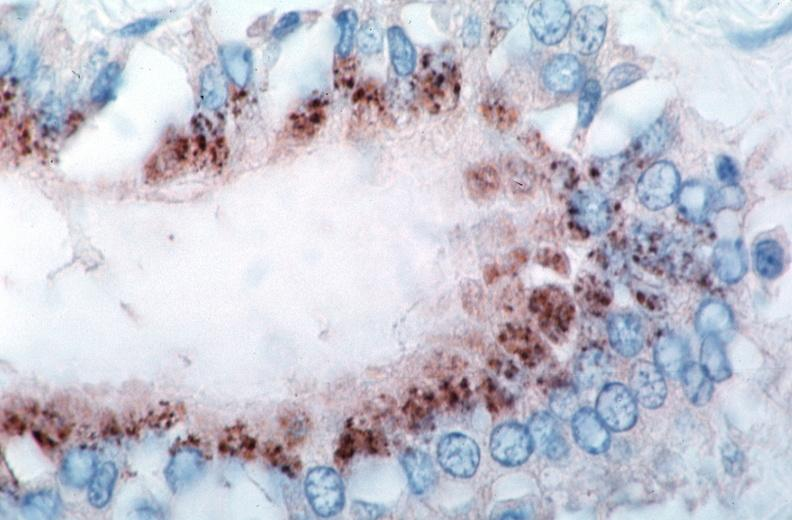s lesion of myocytolysis present?
Answer the question using a single word or phrase. No 